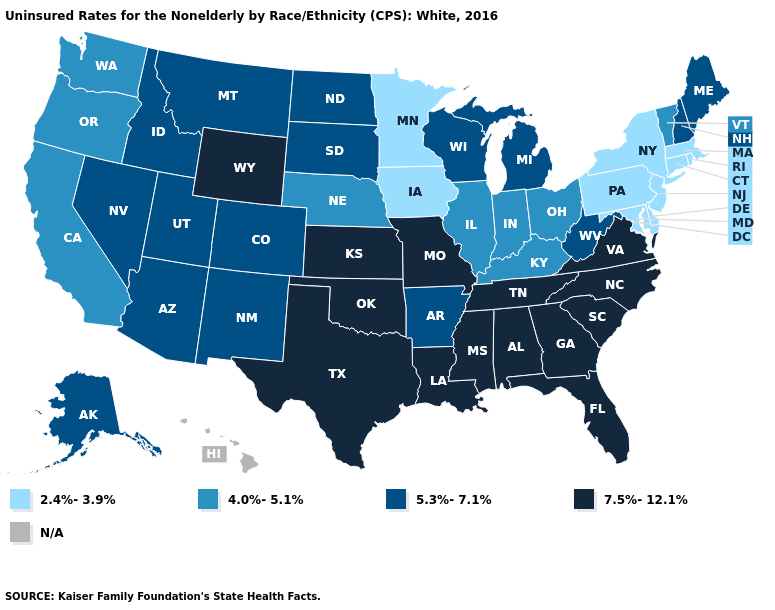Name the states that have a value in the range 5.3%-7.1%?
Quick response, please. Alaska, Arizona, Arkansas, Colorado, Idaho, Maine, Michigan, Montana, Nevada, New Hampshire, New Mexico, North Dakota, South Dakota, Utah, West Virginia, Wisconsin. Which states have the lowest value in the USA?
Keep it brief. Connecticut, Delaware, Iowa, Maryland, Massachusetts, Minnesota, New Jersey, New York, Pennsylvania, Rhode Island. What is the highest value in the USA?
Be succinct. 7.5%-12.1%. What is the highest value in states that border Maine?
Answer briefly. 5.3%-7.1%. What is the value of Kentucky?
Answer briefly. 4.0%-5.1%. What is the highest value in the Northeast ?
Answer briefly. 5.3%-7.1%. What is the highest value in states that border Nebraska?
Be succinct. 7.5%-12.1%. Among the states that border Rhode Island , which have the highest value?
Be succinct. Connecticut, Massachusetts. Which states hav the highest value in the MidWest?
Write a very short answer. Kansas, Missouri. Among the states that border Louisiana , does Texas have the highest value?
Concise answer only. Yes. What is the value of Nebraska?
Quick response, please. 4.0%-5.1%. Which states have the lowest value in the Northeast?
Write a very short answer. Connecticut, Massachusetts, New Jersey, New York, Pennsylvania, Rhode Island. 